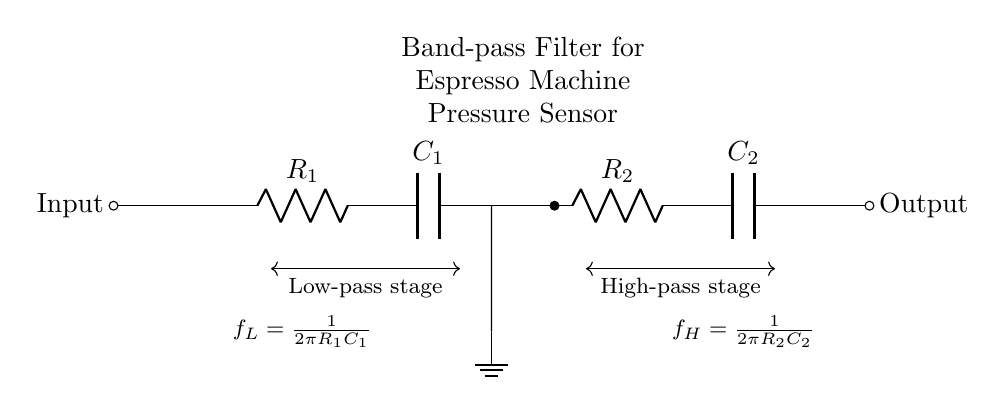What are the two main components used in the low-pass stage? The low-pass stage consists of a resistor and a capacitor. Specifically, it includes resistor R1 and capacitor C1, which allow low-frequency signals to pass while attenuating higher frequencies.
Answer: R1 and C1 What is the purpose of this circuit? The circuit functions as a band-pass filter, designed to isolate a specific frequency range from the input signal, allowing only desired frequencies to pass through while blocking others.
Answer: Band-pass filter What is the formula for the lower cutoff frequency? The formula for the lower cutoff frequency is given as \(f_L = \frac{1}{2\pi R_1C_1}\), which calculates the frequency at which the output begins to drop for lower frequencies based on the values of R1 and C1.
Answer: 1/(2πR1C1) Which stage is responsible for blocking low frequencies? The high-pass stage, which includes resistor R2 and capacitor C2, is designed to block low frequencies from passing through while allowing higher frequencies to reach the output.
Answer: High-pass stage What is the output of this filter connected to? The output of the filter is connected to a node, indicated by the short line marked "Output," which provides the filtered signal for further processing or measurement in the espresso machine.
Answer: Output node What component values control the upper cutoff frequency? The upper cutoff frequency is controlled by the values of R2 and C2, which determine the frequency above which signals are allowed to pass through to the output.
Answer: R2 and C2 